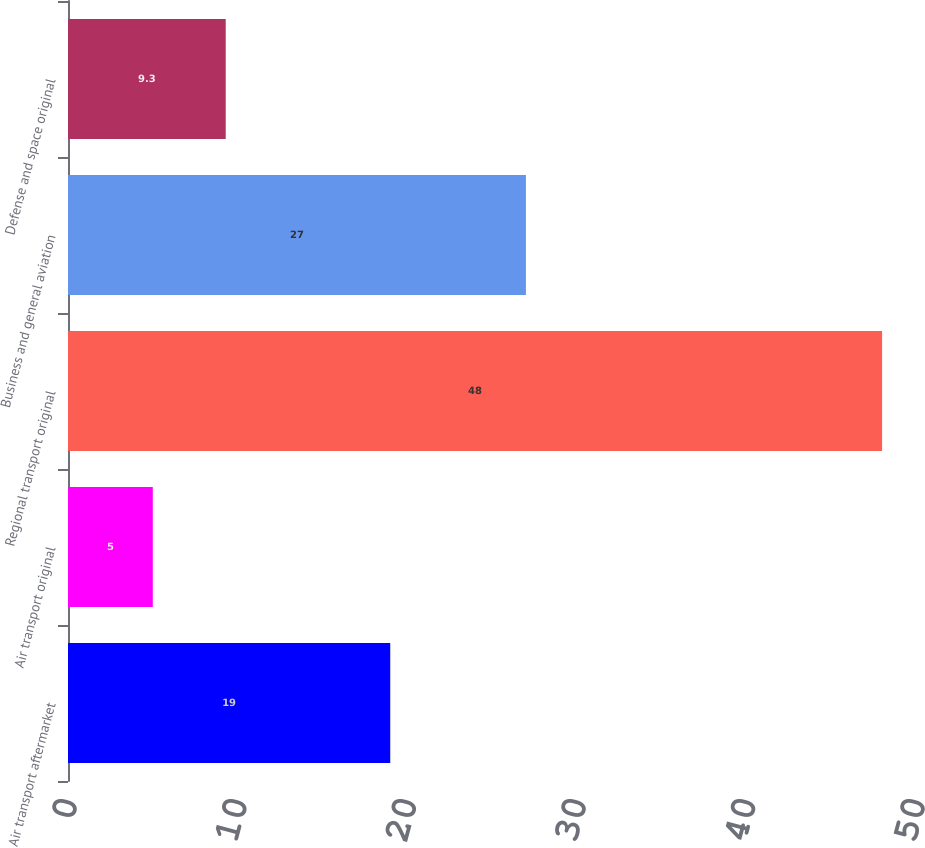Convert chart to OTSL. <chart><loc_0><loc_0><loc_500><loc_500><bar_chart><fcel>Air transport aftermarket<fcel>Air transport original<fcel>Regional transport original<fcel>Business and general aviation<fcel>Defense and space original<nl><fcel>19<fcel>5<fcel>48<fcel>27<fcel>9.3<nl></chart> 